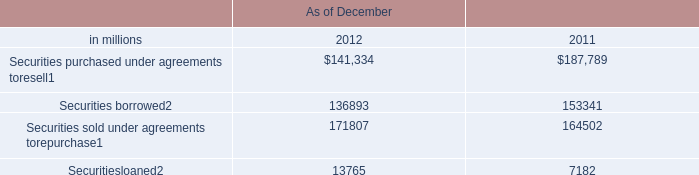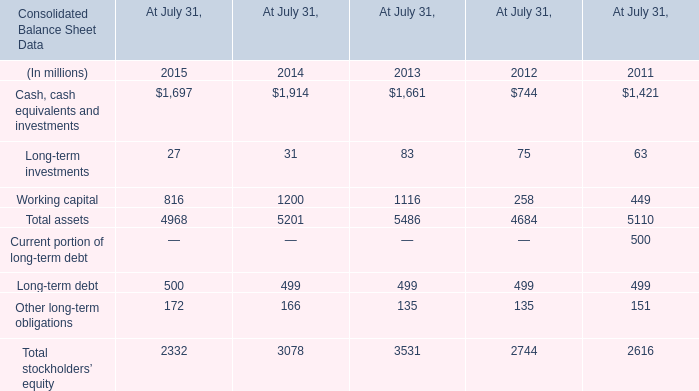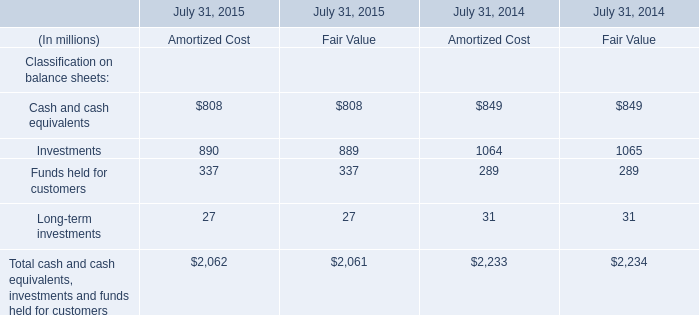What's the sum of Securitiesloaned of As of December 2011, Cash, cash equivalents and investments of At July 31, 2014, and Securities purchased under agreements toresell of As of December 2011 ? 
Computations: ((7182.0 + 1914.0) + 187789.0)
Answer: 196885.0. 